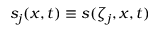Convert formula to latex. <formula><loc_0><loc_0><loc_500><loc_500>s _ { j } ( x , t ) \equiv s ( \zeta _ { j } , x , t )</formula> 